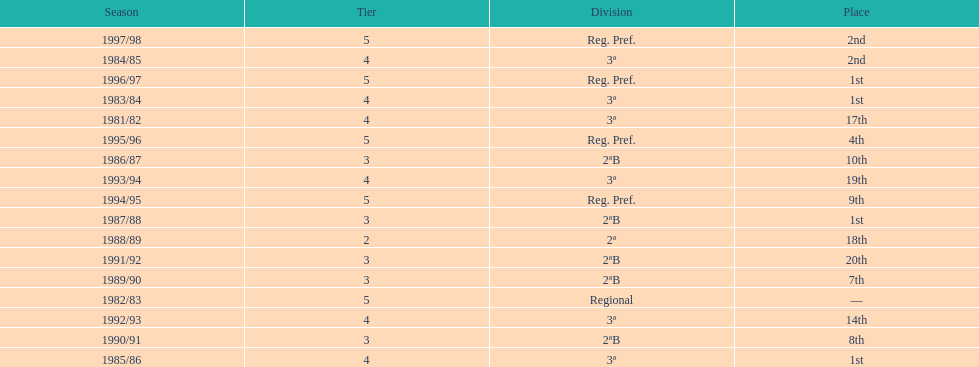Help me parse the entirety of this table. {'header': ['Season', 'Tier', 'Division', 'Place'], 'rows': [['1997/98', '5', 'Reg. Pref.', '2nd'], ['1984/85', '4', '3ª', '2nd'], ['1996/97', '5', 'Reg. Pref.', '1st'], ['1983/84', '4', '3ª', '1st'], ['1981/82', '4', '3ª', '17th'], ['1995/96', '5', 'Reg. Pref.', '4th'], ['1986/87', '3', '2ªB', '10th'], ['1993/94', '4', '3ª', '19th'], ['1994/95', '5', 'Reg. Pref.', '9th'], ['1987/88', '3', '2ªB', '1st'], ['1988/89', '2', '2ª', '18th'], ['1991/92', '3', '2ªB', '20th'], ['1989/90', '3', '2ªB', '7th'], ['1982/83', '5', 'Regional', '—'], ['1992/93', '4', '3ª', '14th'], ['1990/91', '3', '2ªB', '8th'], ['1985/86', '4', '3ª', '1st']]} How many years were they in tier 3 5. 